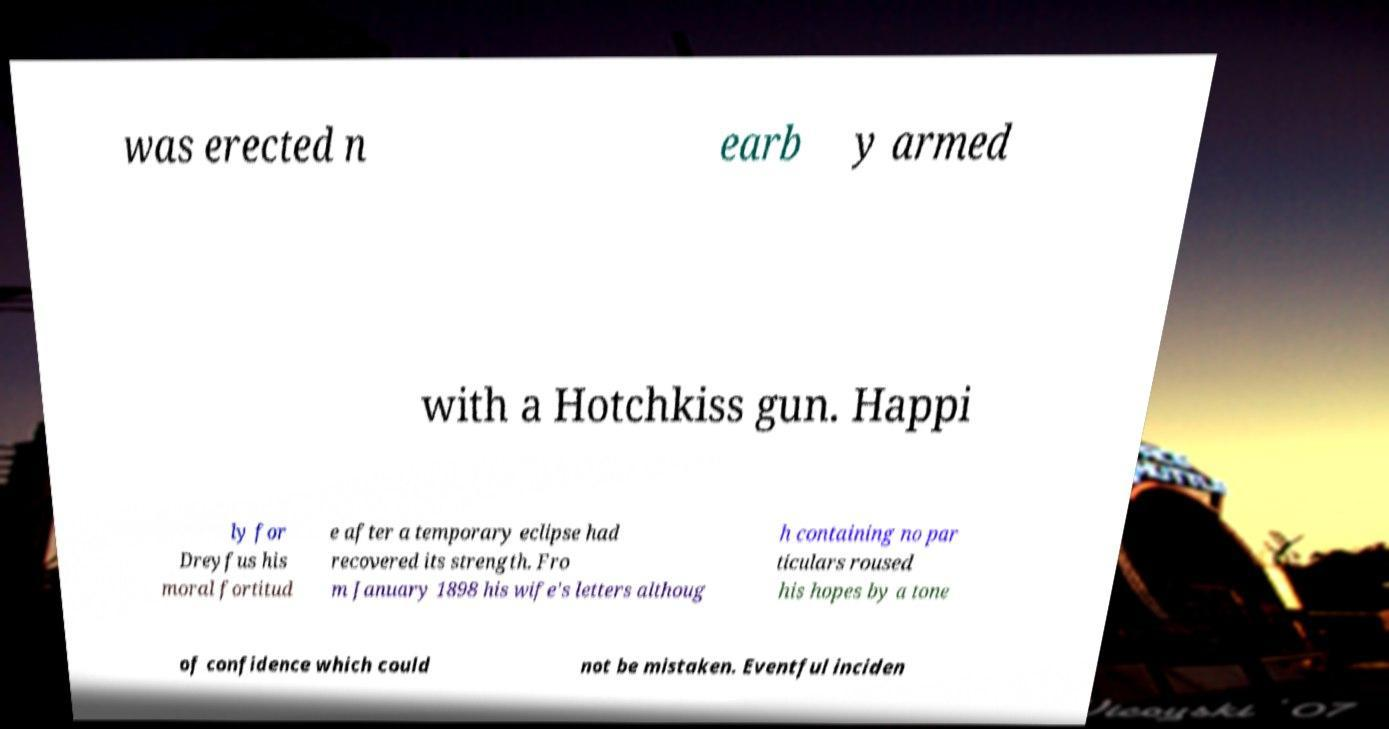There's text embedded in this image that I need extracted. Can you transcribe it verbatim? was erected n earb y armed with a Hotchkiss gun. Happi ly for Dreyfus his moral fortitud e after a temporary eclipse had recovered its strength. Fro m January 1898 his wife's letters althoug h containing no par ticulars roused his hopes by a tone of confidence which could not be mistaken. Eventful inciden 